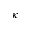<formula> <loc_0><loc_0><loc_500><loc_500>\kappa</formula> 